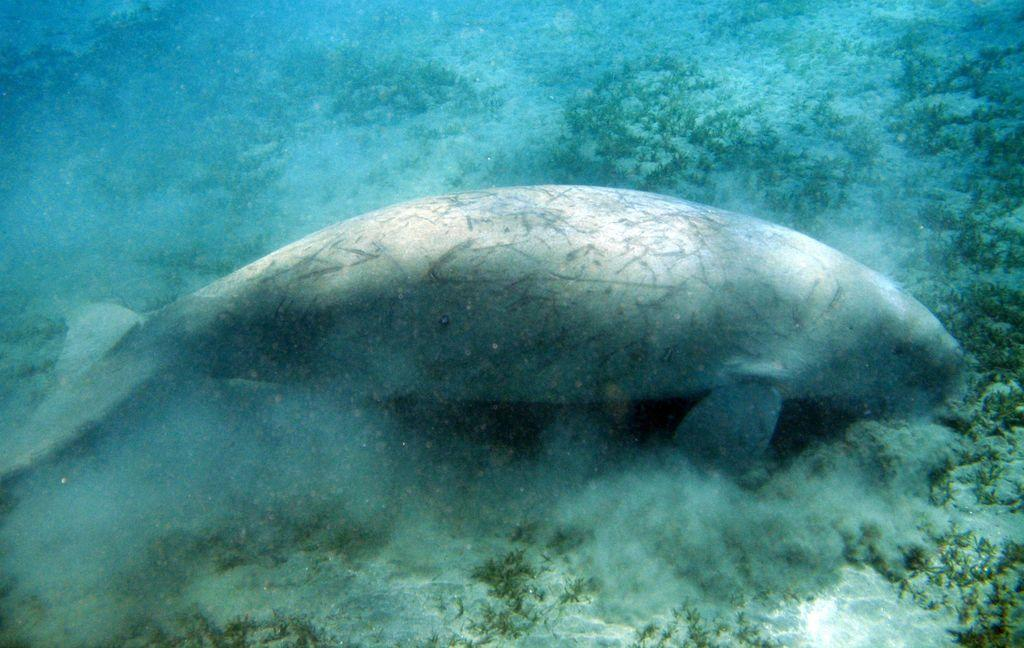What type of animal can be seen in the water in the image? There is a fish in the water in the image. What is beneath the fish in the water? There is sand beneath the fish. What is the environment like around the fish? There is grass beneath the fish. What type of coat is the horse wearing in the image? There is no horse or coat present in the image; it features a fish in the water with sand and grass beneath it. 